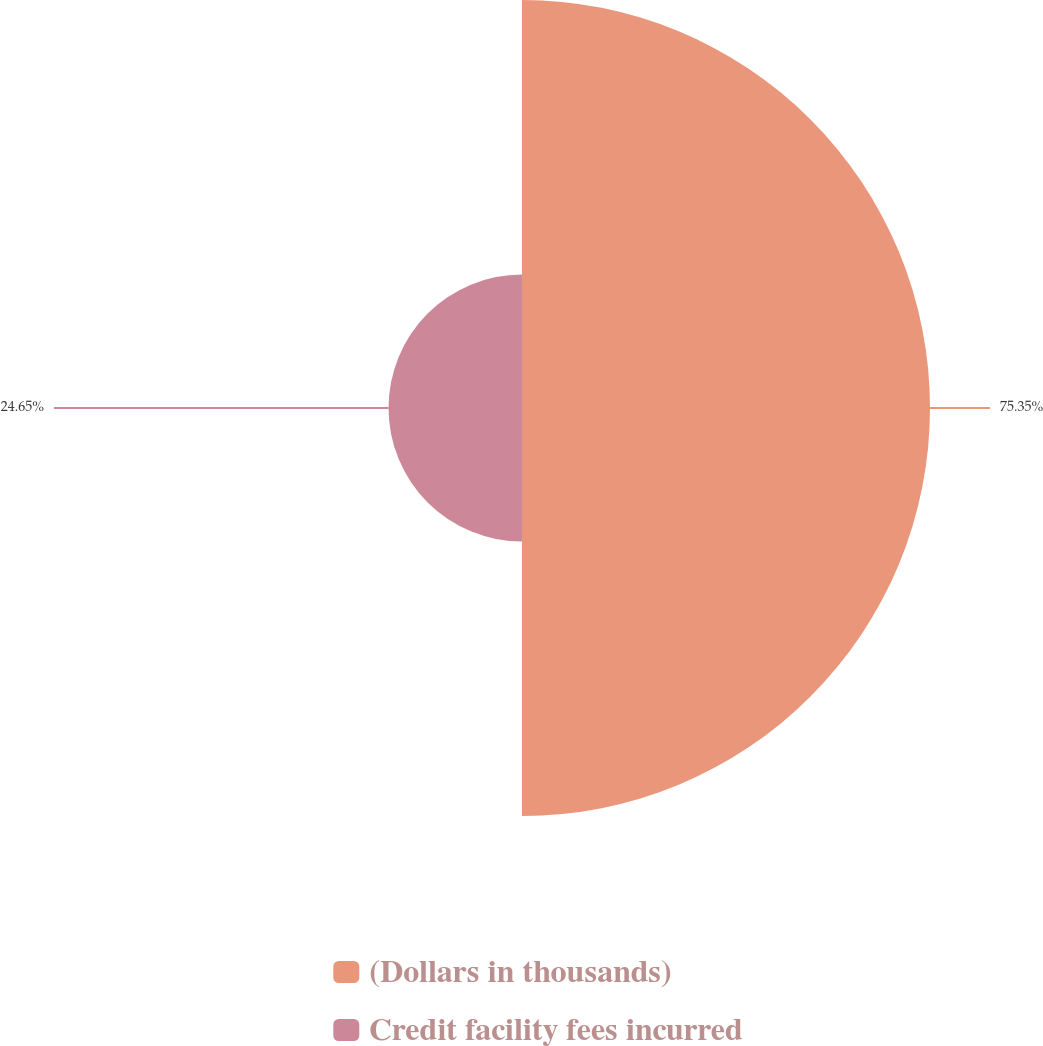Convert chart. <chart><loc_0><loc_0><loc_500><loc_500><pie_chart><fcel>(Dollars in thousands)<fcel>Credit facility fees incurred<nl><fcel>75.35%<fcel>24.65%<nl></chart> 